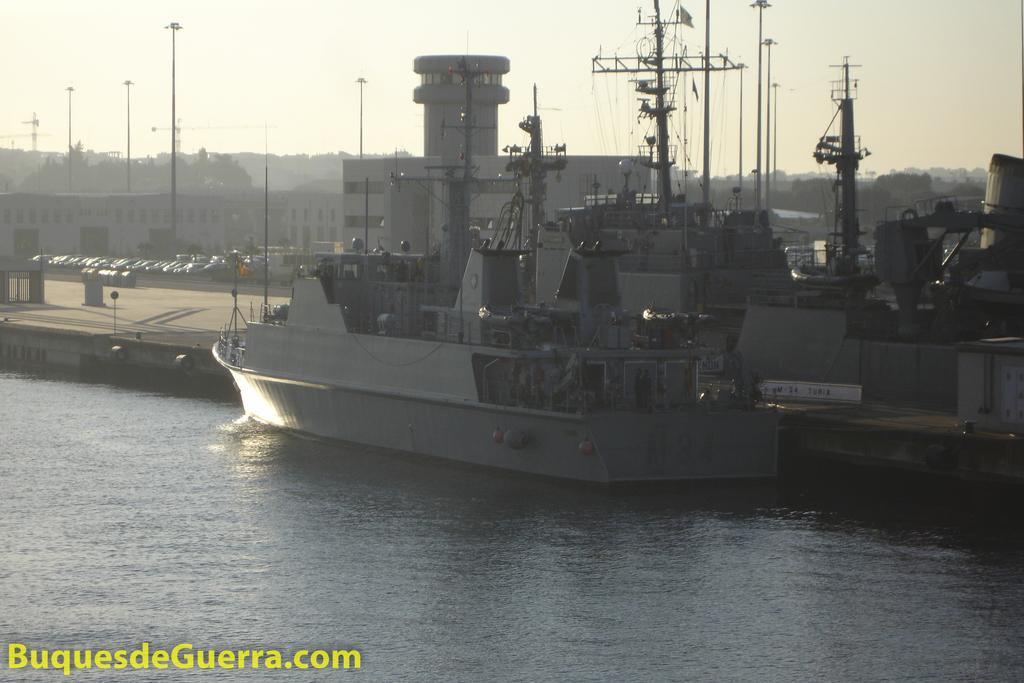Describe this image in one or two sentences. In the center of the image we can see a ship with some poles, metal frames and some balls. On the right side of the image we can see some towers. On the left side of the image we can see group of vehicles parked on the ground. In the background, we can see a group of buildings with windows and some trees. At the top of the image we can see the sky. 